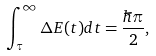<formula> <loc_0><loc_0><loc_500><loc_500>\int _ { \tau } ^ { \infty } \Delta E ( t ) d t = \frac { \hbar { \pi } } { 2 } ,</formula> 